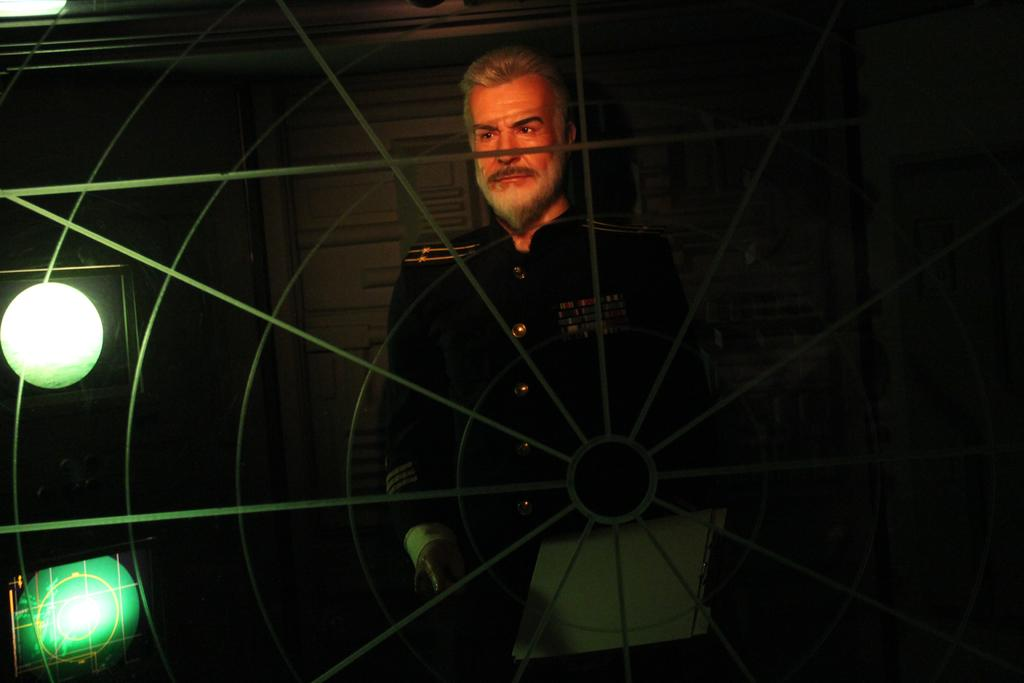What is the main object in the image? There is a wheel in the image. What is the person in the image doing with the wheel? A person is standing through the wheel. What can be seen in the background of the image? There is a wall, lights, and some objects in the background of the image. How would you describe the lighting in the background? The background view is dark. Where is the nearest park to the location of the wheel in the image? There is no information about a park or its location in the image. --- Facts: 1. There is a person holding a book in the image. 2. The person is sitting on a chair. 3. There is a table in front of the person. 4. The table has a lamp on it. 5. The background of the image is a room. Absurd Topics: ocean, fish, boat Conversation: What is the person in the image holding? The person is holding a book in the image. What is the person's position in the image? The person is sitting on a chair. What object is in front of the person? There is a table in front of the person. What is on the table? The table has a lamp on it. Where is the scene taking place? The background of the image is a room. Reasoning: Let's think step by step in order to produce the conversation. We start by identifying the main subject in the image, which is the person holding a book. Then, we describe the person's position and the objects around them, such as the chair, table, and lamp. Finally, we mention the setting of the scene, which is a room. Absurd Question/Answer: Can you see any fish swimming in the ocean in the image? There is no ocean or fish present in the image; it takes place in a room with a person sitting at a table. 